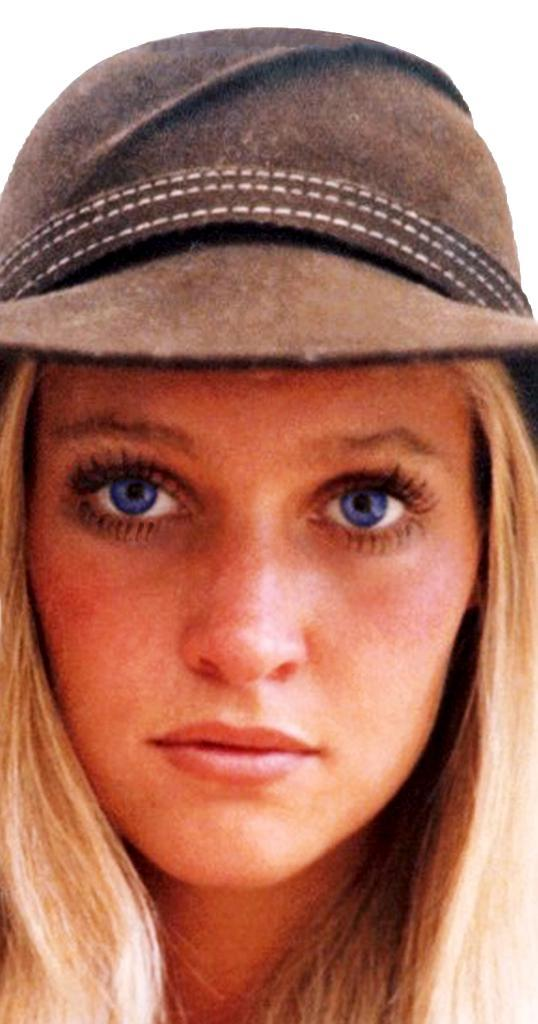Who is present in the image? There is a woman in the image. What is the woman wearing on her head? The woman is wearing a cap. What arithmetic problem is the woman attempting to solve in the image? There is no arithmetic problem present in the image, as it only features a woman wearing a cap. 